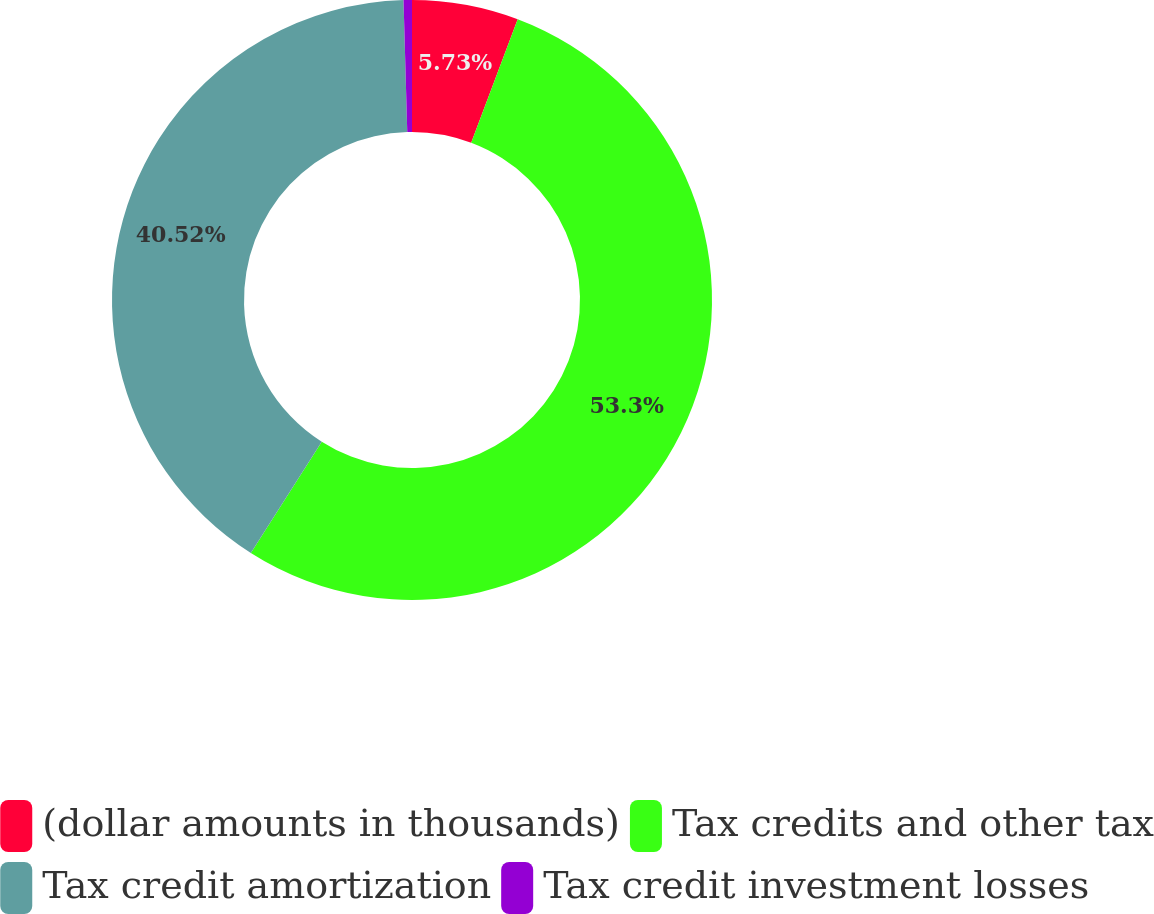<chart> <loc_0><loc_0><loc_500><loc_500><pie_chart><fcel>(dollar amounts in thousands)<fcel>Tax credits and other tax<fcel>Tax credit amortization<fcel>Tax credit investment losses<nl><fcel>5.73%<fcel>53.29%<fcel>40.52%<fcel>0.45%<nl></chart> 